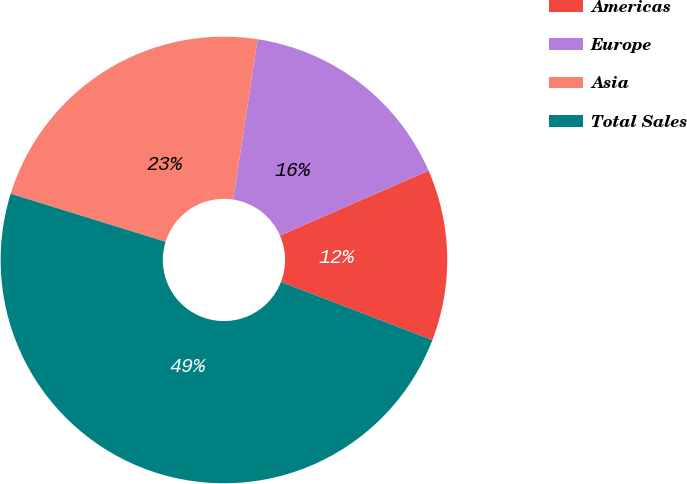Convert chart. <chart><loc_0><loc_0><loc_500><loc_500><pie_chart><fcel>Americas<fcel>Europe<fcel>Asia<fcel>Total Sales<nl><fcel>12.39%<fcel>16.04%<fcel>22.62%<fcel>48.95%<nl></chart> 